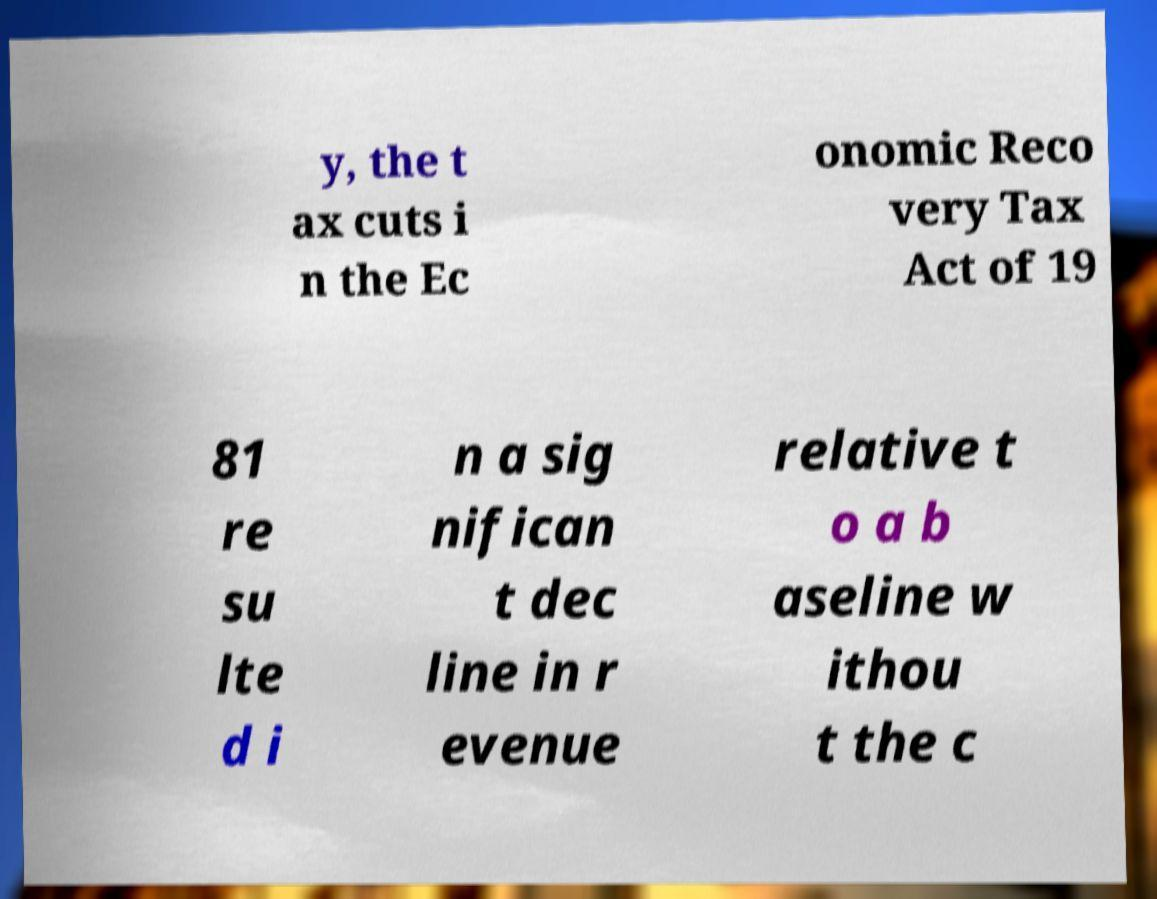What messages or text are displayed in this image? I need them in a readable, typed format. y, the t ax cuts i n the Ec onomic Reco very Tax Act of 19 81 re su lte d i n a sig nifican t dec line in r evenue relative t o a b aseline w ithou t the c 